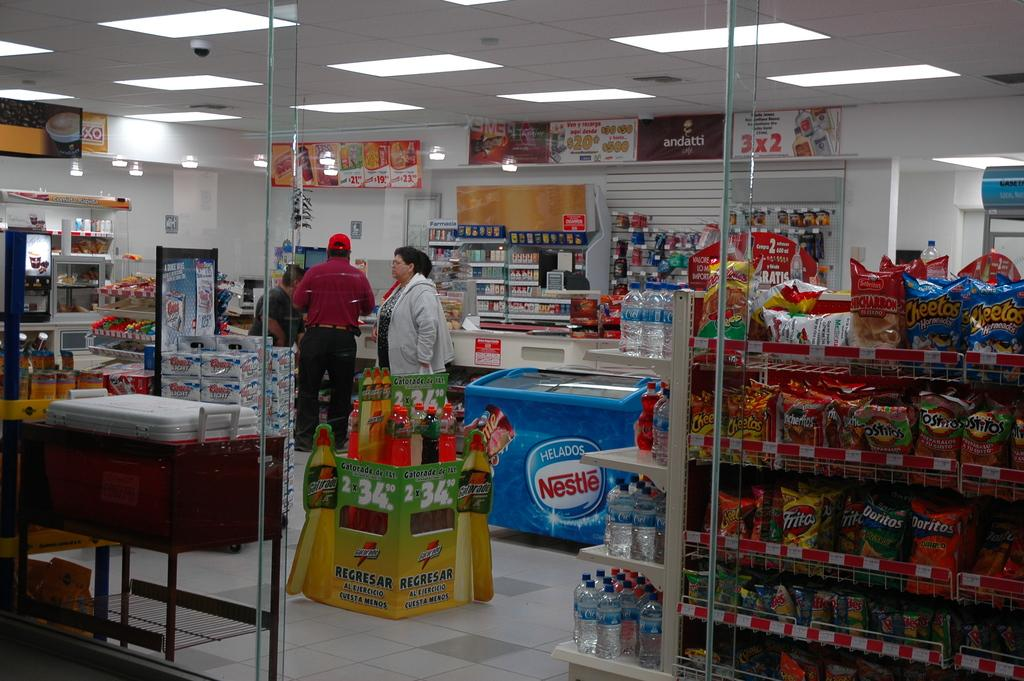<image>
Present a compact description of the photo's key features. Looking at a check out with a Nestle ice cream freezer 